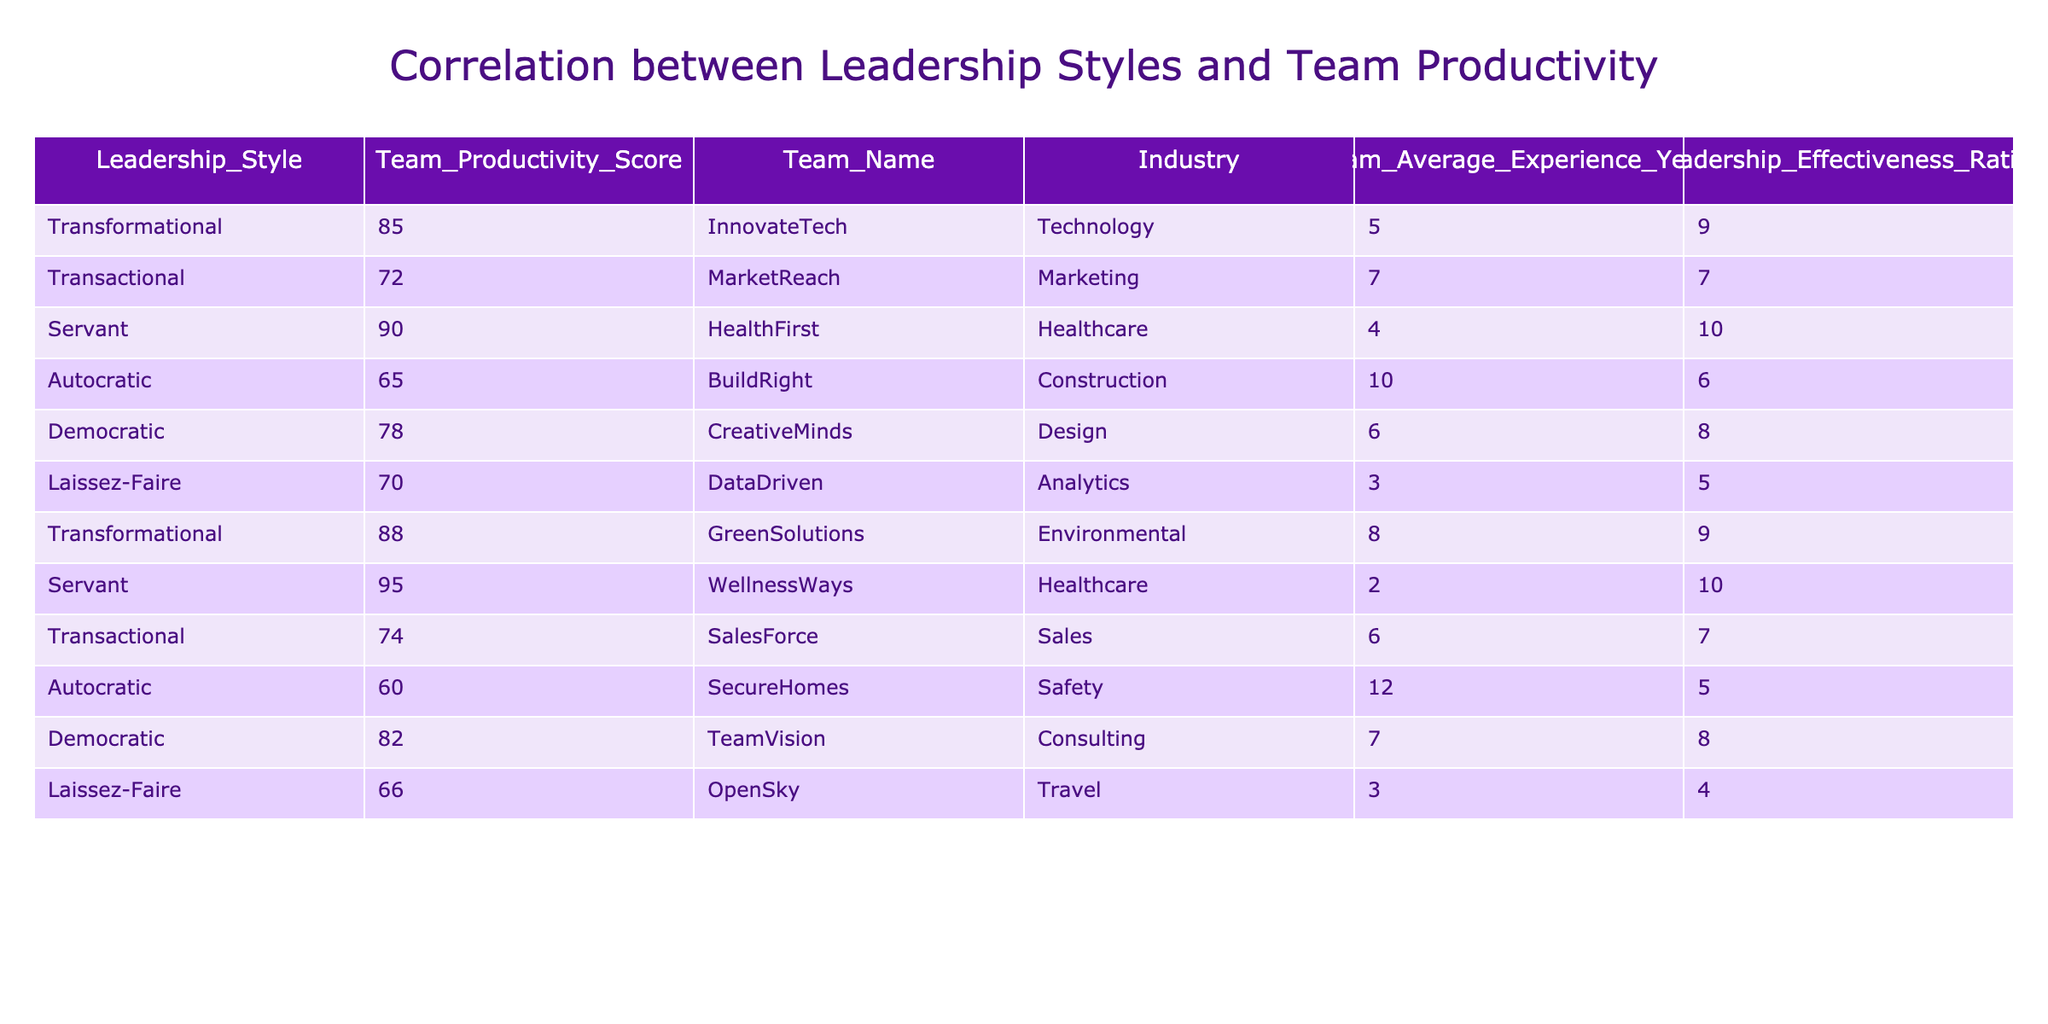What is the productivity score of the team with a transformational leadership style? There are two teams with a transformational leadership style: InnovateTech with a score of 85 and GreenSolutions with a score of 88. Therefore, the productivity scores are 85 and 88.
Answer: 85 and 88 Which team demonstrates the highest productivity score? By inspecting the table, the team with the highest productivity score is WellnessWays with a score of 95.
Answer: 95 What is the average team productivity score for the healthcare industry? The healthcare teams are HealthFirst with a score of 90 and WellnessWays with a score of 95. To find the average, we sum these scores (90 + 95 = 185) and divide by the number of teams (2). Thus, the average productivity score is 185/2 = 92.5.
Answer: 92.5 Is there any team with a productivity score below 70? Looking at the table, the teams Autocratic (BuildRight) and Laissez-Faire (OpenSky) have scores below 70 (65 and 66). Thus, it is true that there are teams with scores below 70.
Answer: Yes What is the difference in productivity scores between the highest and lowest rated team? The highest score is from WellnessWays with 95 and the lowest is from SecureHomes with 60. The difference is thus 95 - 60 = 35.
Answer: 35 What is the average leadership effectiveness rating for the teams that have a democratic leadership style? The teams with a democratic leadership style are CreativeMinds with a rating of 8 and TeamVision with a rating of 8. To find the average, we sum these ratings (8 + 8 = 16) and divide by the number of teams (2). So, the average is 16/2 = 8.
Answer: 8 Which leadership style contributes the most towards productivity based on the table? Transformational and Servant leadership styles have the highest scores (85, 88 for Transformational; 90, 95 for Servant). Comparing these, Servant has the highest average score (92.5) among its teams compared to Transformational (86.5). Thus, Servant contributes the most towards productivity.
Answer: Servant How many teams have a leadership effectiveness rating of 9 or higher? The teams that meet this criterion are InnovateTech (9), HealthFirst (10), GreenSolutions (9), and WellnessWays (10). Therefore, there are four teams with effectiveness ratings of 9 or higher.
Answer: 4 What is the percentage of teams in the healthcare industry with a productivity score above 90? There are two teams in the healthcare industry: HealthFirst (90) and WellnessWays (95). Only WellnessWays has a score above 90, giving us a percentage of 1 out of 2 teams, which is 50%.
Answer: 50% 